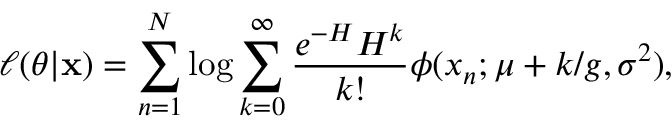Convert formula to latex. <formula><loc_0><loc_0><loc_500><loc_500>\ell ( \theta | \mathbf x ) = \sum _ { n = 1 } ^ { N } \log \sum _ { k = 0 } ^ { \infty } \frac { e ^ { - H } H ^ { k } } { k ! } \phi ( x _ { n } ; \mu + k / g , \sigma ^ { 2 } ) ,</formula> 